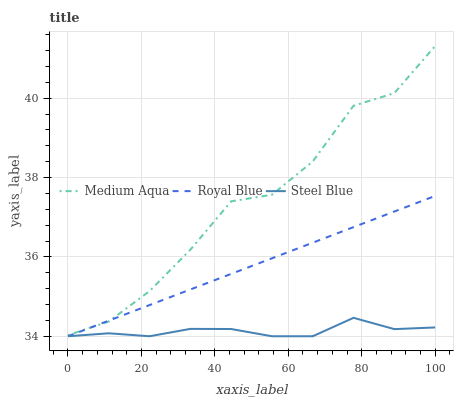Does Steel Blue have the minimum area under the curve?
Answer yes or no. Yes. Does Medium Aqua have the maximum area under the curve?
Answer yes or no. Yes. Does Medium Aqua have the minimum area under the curve?
Answer yes or no. No. Does Steel Blue have the maximum area under the curve?
Answer yes or no. No. Is Royal Blue the smoothest?
Answer yes or no. Yes. Is Medium Aqua the roughest?
Answer yes or no. Yes. Is Steel Blue the smoothest?
Answer yes or no. No. Is Steel Blue the roughest?
Answer yes or no. No. Does Medium Aqua have the lowest value?
Answer yes or no. No. Does Medium Aqua have the highest value?
Answer yes or no. Yes. Does Steel Blue have the highest value?
Answer yes or no. No. Is Steel Blue less than Medium Aqua?
Answer yes or no. Yes. Is Medium Aqua greater than Steel Blue?
Answer yes or no. Yes. Does Royal Blue intersect Steel Blue?
Answer yes or no. Yes. Is Royal Blue less than Steel Blue?
Answer yes or no. No. Is Royal Blue greater than Steel Blue?
Answer yes or no. No. Does Steel Blue intersect Medium Aqua?
Answer yes or no. No. 